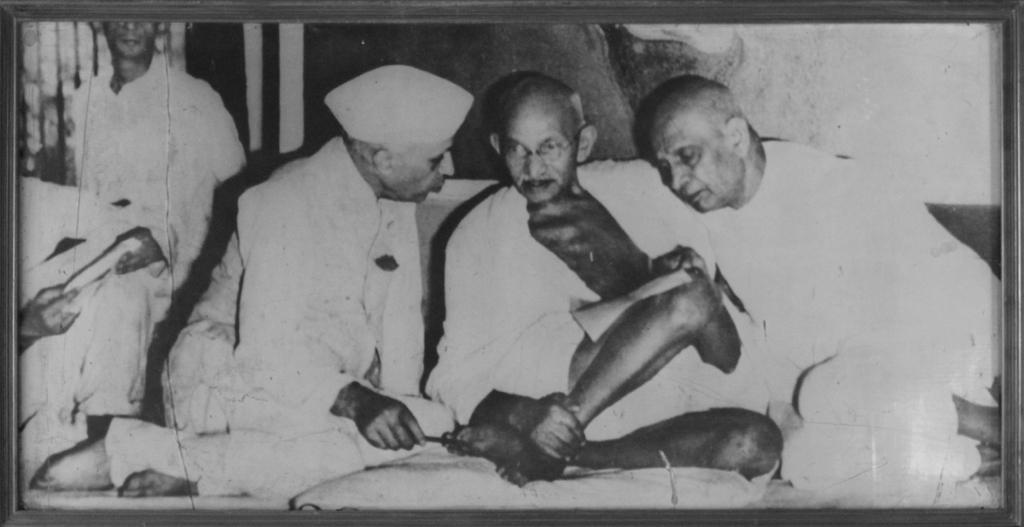What are the people in the image doing? The people in the image are sitting. What is the color scheme of the image? The image is black and white in color. What type of bean is being used to create the lace pattern on the bushes in the image? There are no beans, lace, or bushes present in the image. 